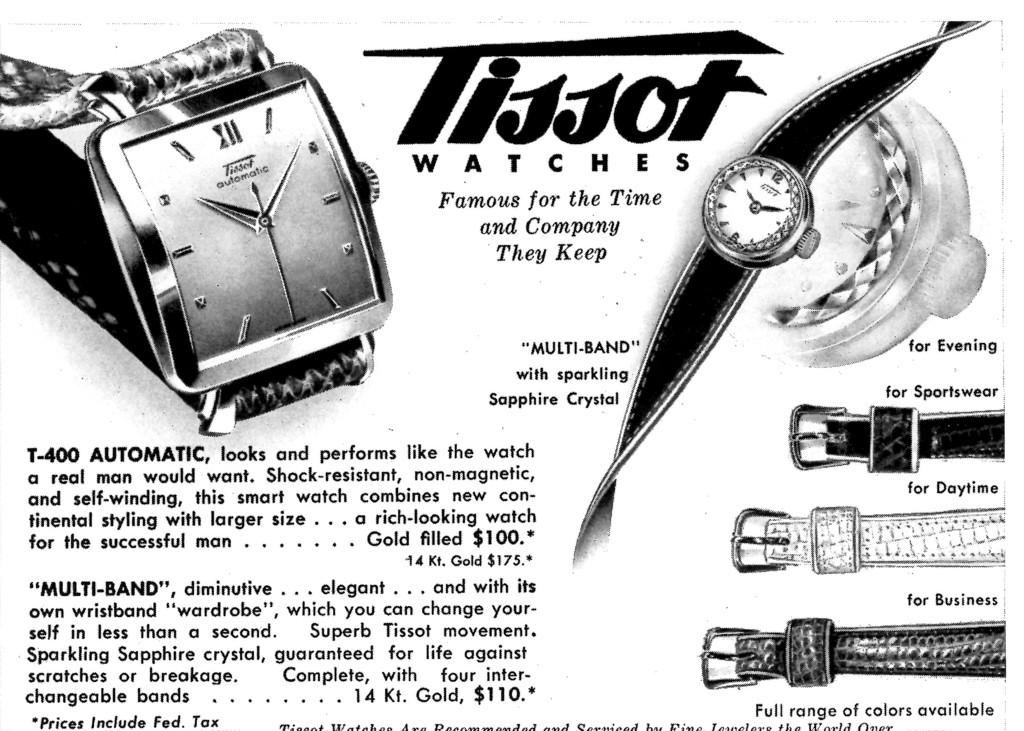<image>
Share a concise interpretation of the image provided. the article is advertising Tissot watches for various accasions 